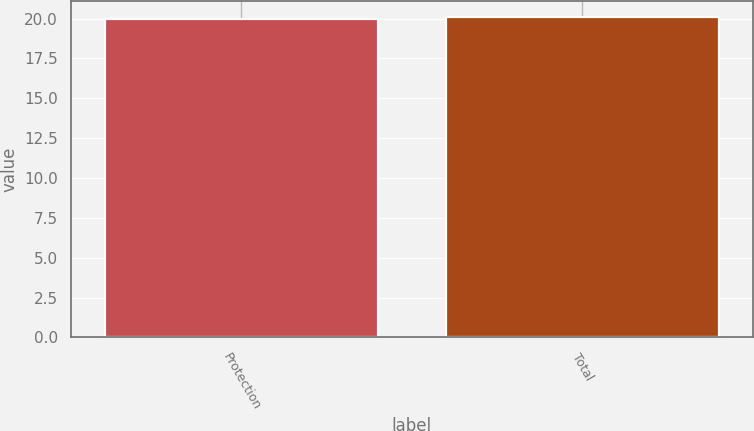Convert chart to OTSL. <chart><loc_0><loc_0><loc_500><loc_500><bar_chart><fcel>Protection<fcel>Total<nl><fcel>20<fcel>20.1<nl></chart> 